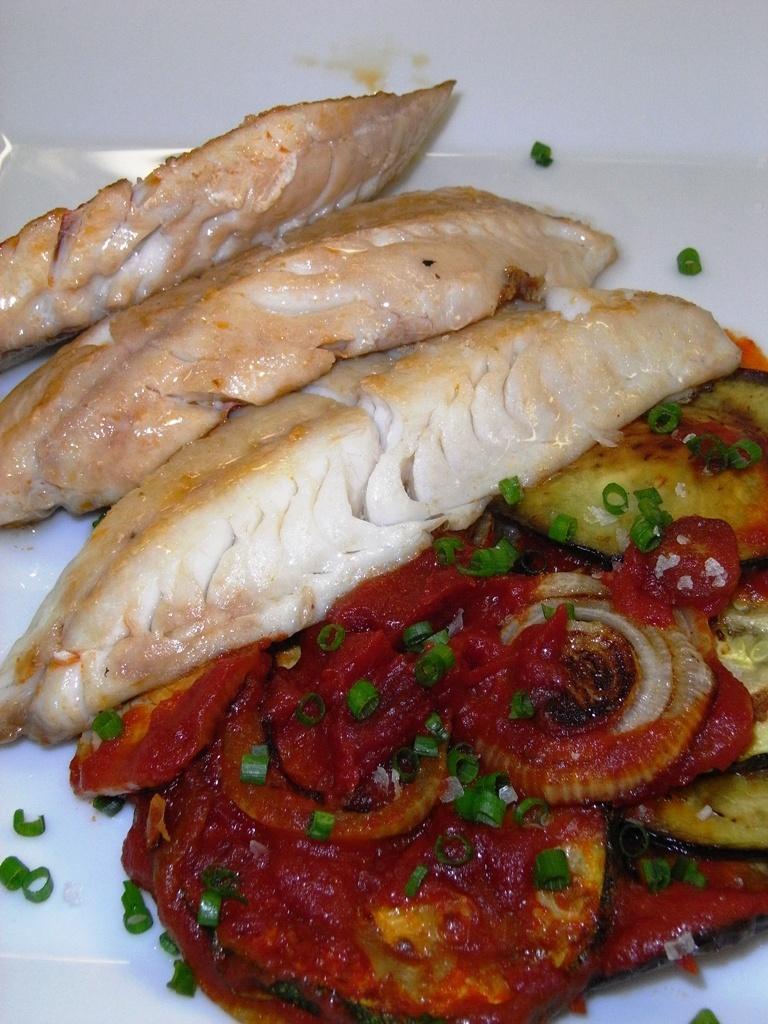Can you describe this image briefly? In this picture there are different food items on the white plate. At the back it might be a table. 